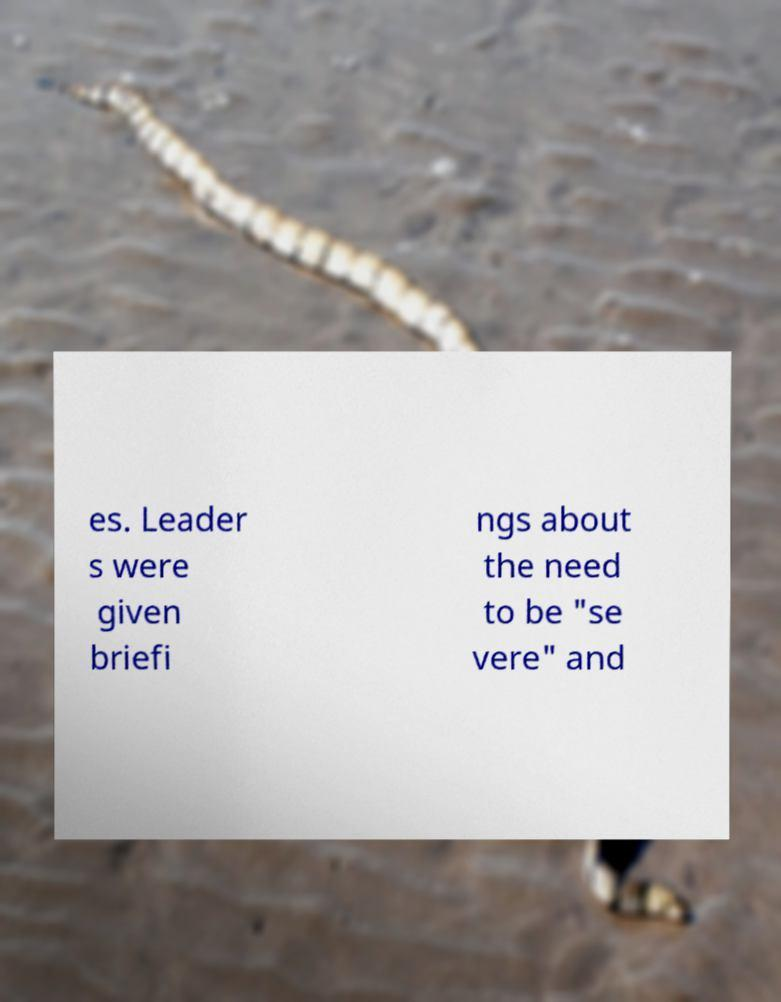For documentation purposes, I need the text within this image transcribed. Could you provide that? es. Leader s were given briefi ngs about the need to be "se vere" and 